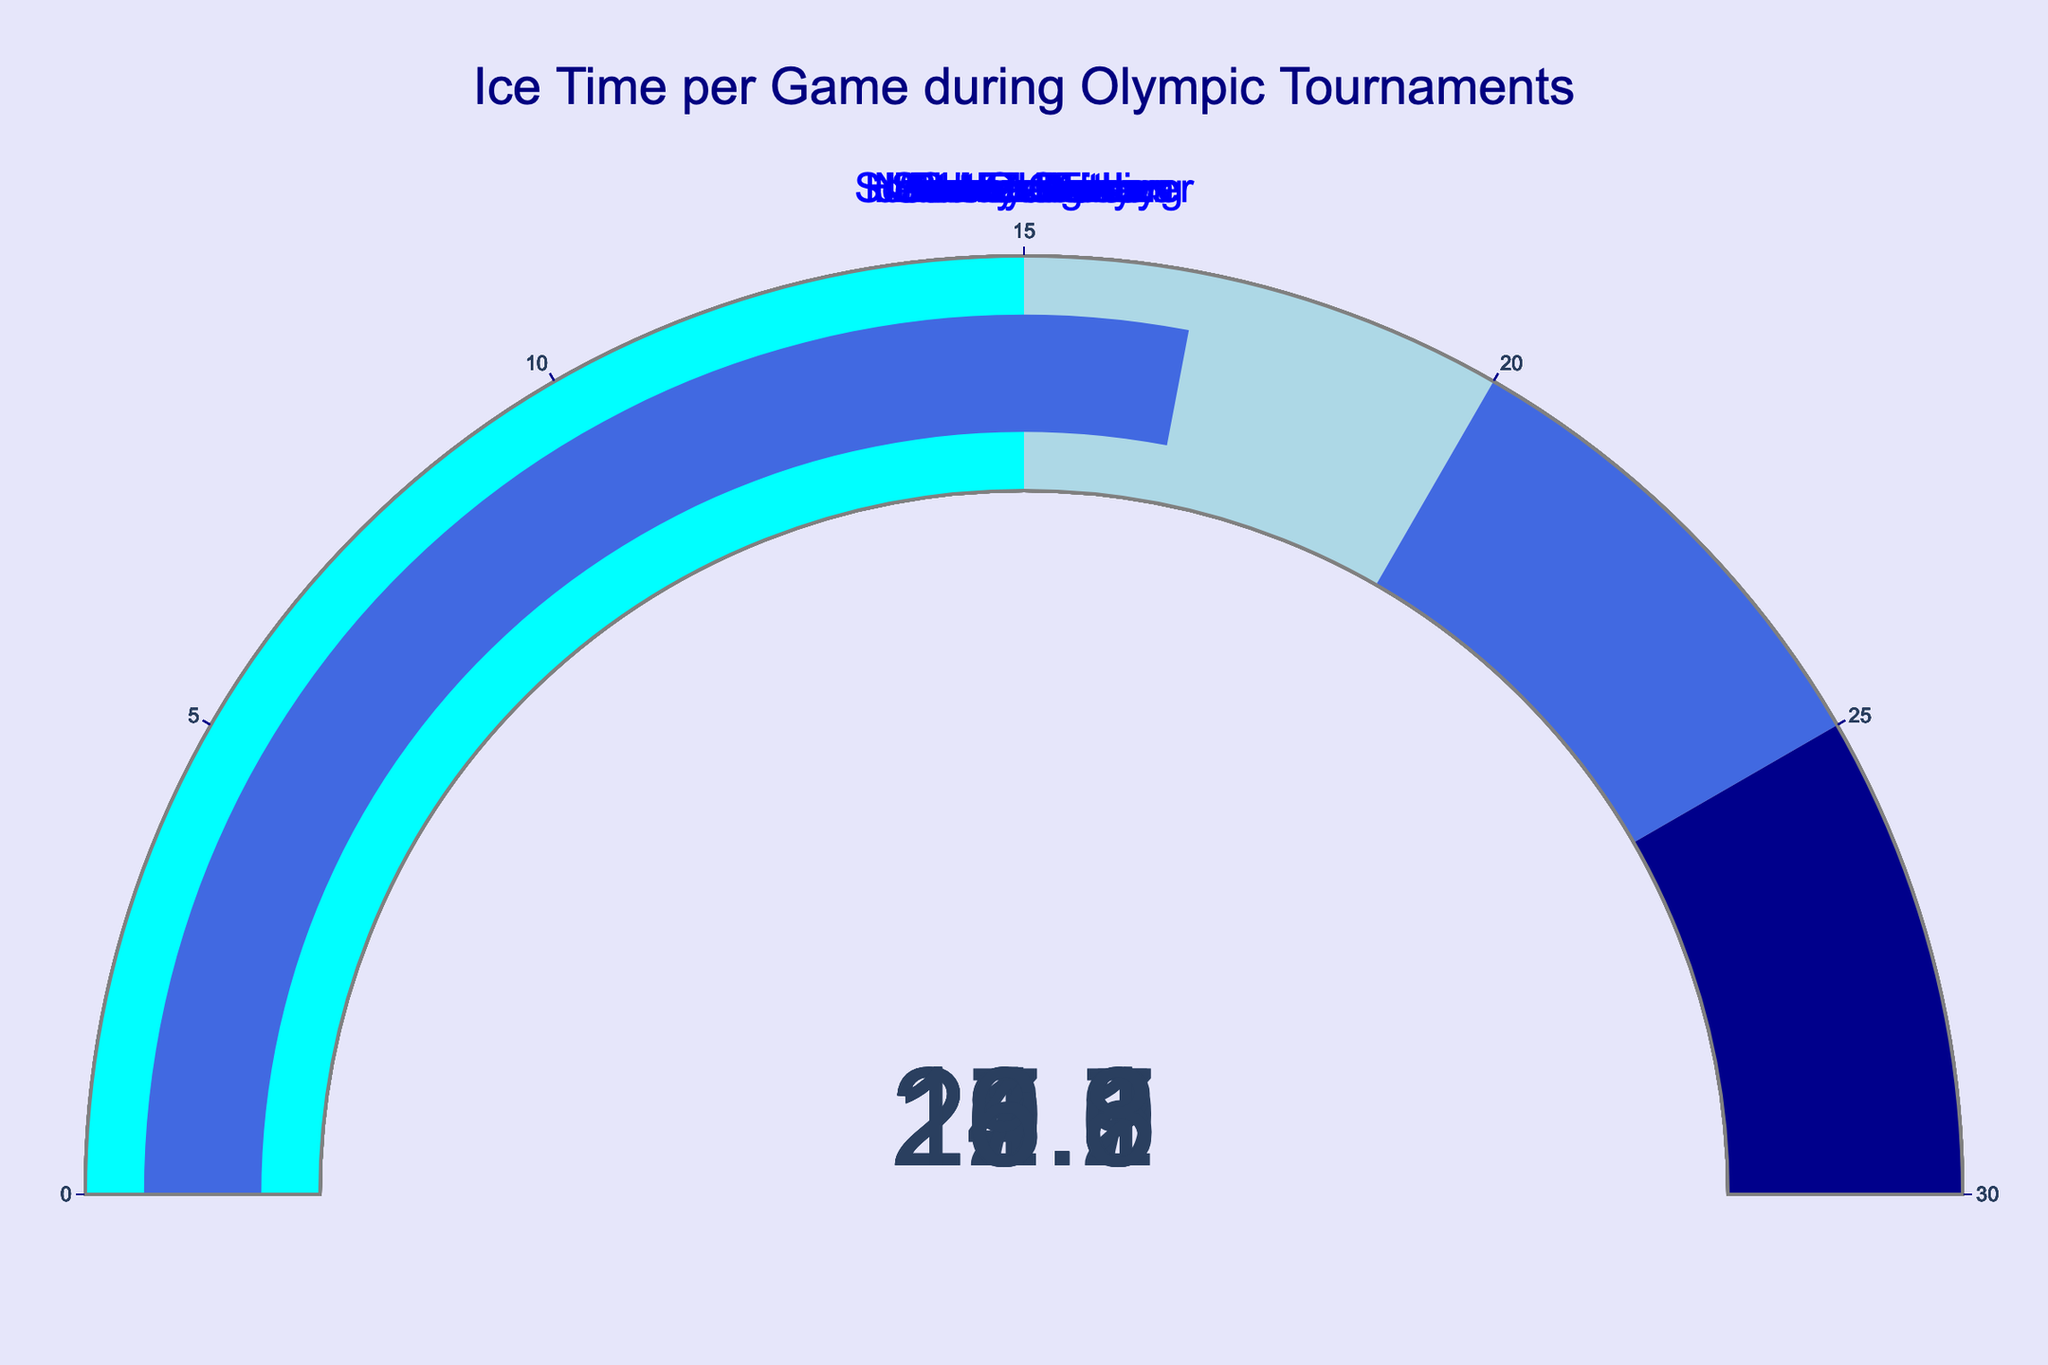What's the highest ice time recorded by any player in the figure? Observing the gauge chart, Scott Niedermayer has the highest ice time of 24.2 minutes.
Answer: 24.2 minutes How many players have an ice time greater than 20 minutes? By counting the gauges showing values above 20, we see that Sidney Crosby, Alex Ovechkin, Nicklas Lidstrom, and Scott Niedermayer have ice times above 20 minutes.
Answer: 4 players What's the average ice time among all the players? Sum the ice times (22.5 + 21.8 + 20.3 + 19.7 + 18.9 + 23.1 + 24.2 + 17.6 + 19.1 + 16.8), which equals 203.9, then divide by the number of players (10): 203.9 / 10 = 20.39 minutes.
Answer: 20.39 minutes Which player has less ice time than Sidney Crosby but more than Jarome Iginla? Sidney Crosby's ice time is 22.5 minutes, and Jarome Iginla's is 20.3 minutes. Alex Ovechkin, with 21.8 minutes, falls in between them.
Answer: Alex Ovechkin What's the difference in ice time between the player with the highest ice time and the player with the lowest ice time? Scott Niedermayer has the highest ice time (24.2 minutes), and Corey Perry has the lowest (16.8 minutes). The difference is 24.2 - 16.8 = 7.4 minutes.
Answer: 7.4 minutes What color is the bar for the player with the lowest ice time? The gauge chart for Corey Perry, who has the lowest ice time at 16.8 minutes, indicates the bar is in the cyan range (0-15), but moves slightly into the light blue range (15-20).
Answer: Cyan (with a touch of light blue) How many players have ice times that fall into the cyan range (0-15 minutes)? By observing the gauges, no player's ice time is below 15 minutes, which means none fall in the cyan range.
Answer: 0 players Which player's ice time is closest to the average ice time? The average ice time is 20.39 minutes. Jarome Iginla, with 20.3 minutes, is the closest to this average.
Answer: Jarome Iginla Who has a higher ice time, Jonathan Toews or Joe Thornton? Jonathan Toews has an ice time of 19.1 minutes, while Joe Thornton has 17.6 minutes. Therefore, Jonathan Toews has the higher ice time.
Answer: Jonathan Toews 